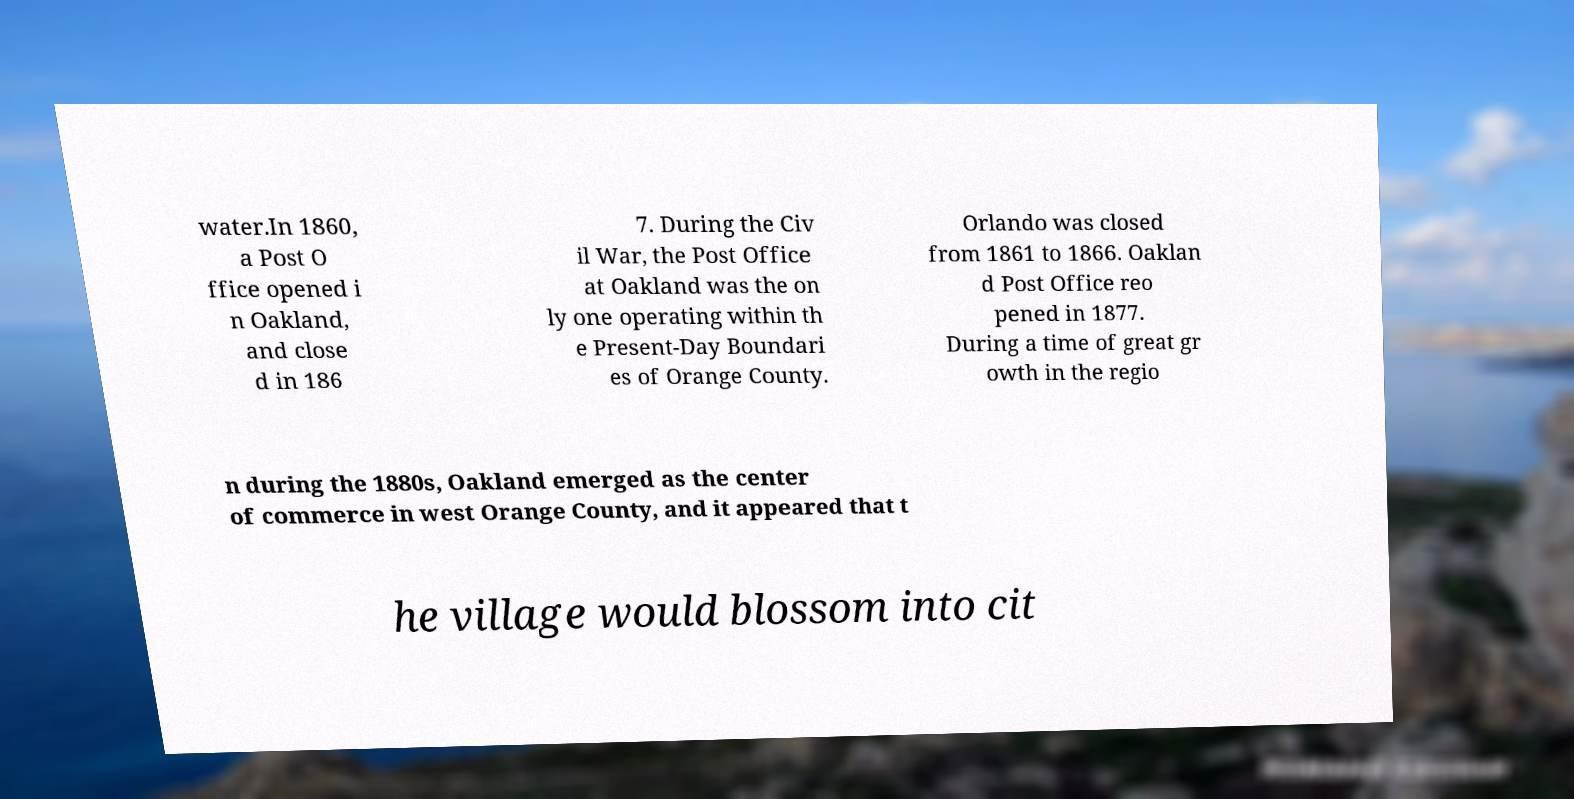Could you extract and type out the text from this image? water.In 1860, a Post O ffice opened i n Oakland, and close d in 186 7. During the Civ il War, the Post Office at Oakland was the on ly one operating within th e Present-Day Boundari es of Orange County. Orlando was closed from 1861 to 1866. Oaklan d Post Office reo pened in 1877. During a time of great gr owth in the regio n during the 1880s, Oakland emerged as the center of commerce in west Orange County, and it appeared that t he village would blossom into cit 